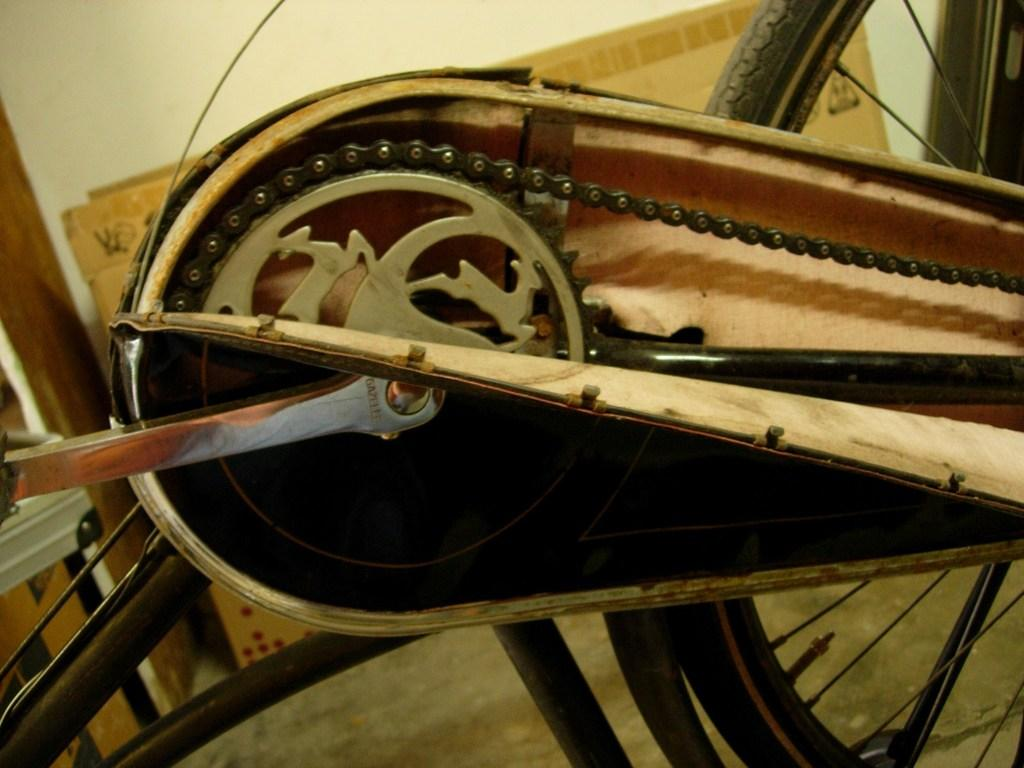What type of vehicle part is shown in the image? The image contains a bi-cycle part. What specific components are included in the bi-cycle part? The bi-cycle part includes a Tyre, a chain, a pedal, spokes, and rods. What is the background of the image? The bi-cycle part is visible in front of a wall. How many friends are visible in the image wearing hats? There are no friends or hats present in the image; it features a bi-cycle part in front of a wall. 